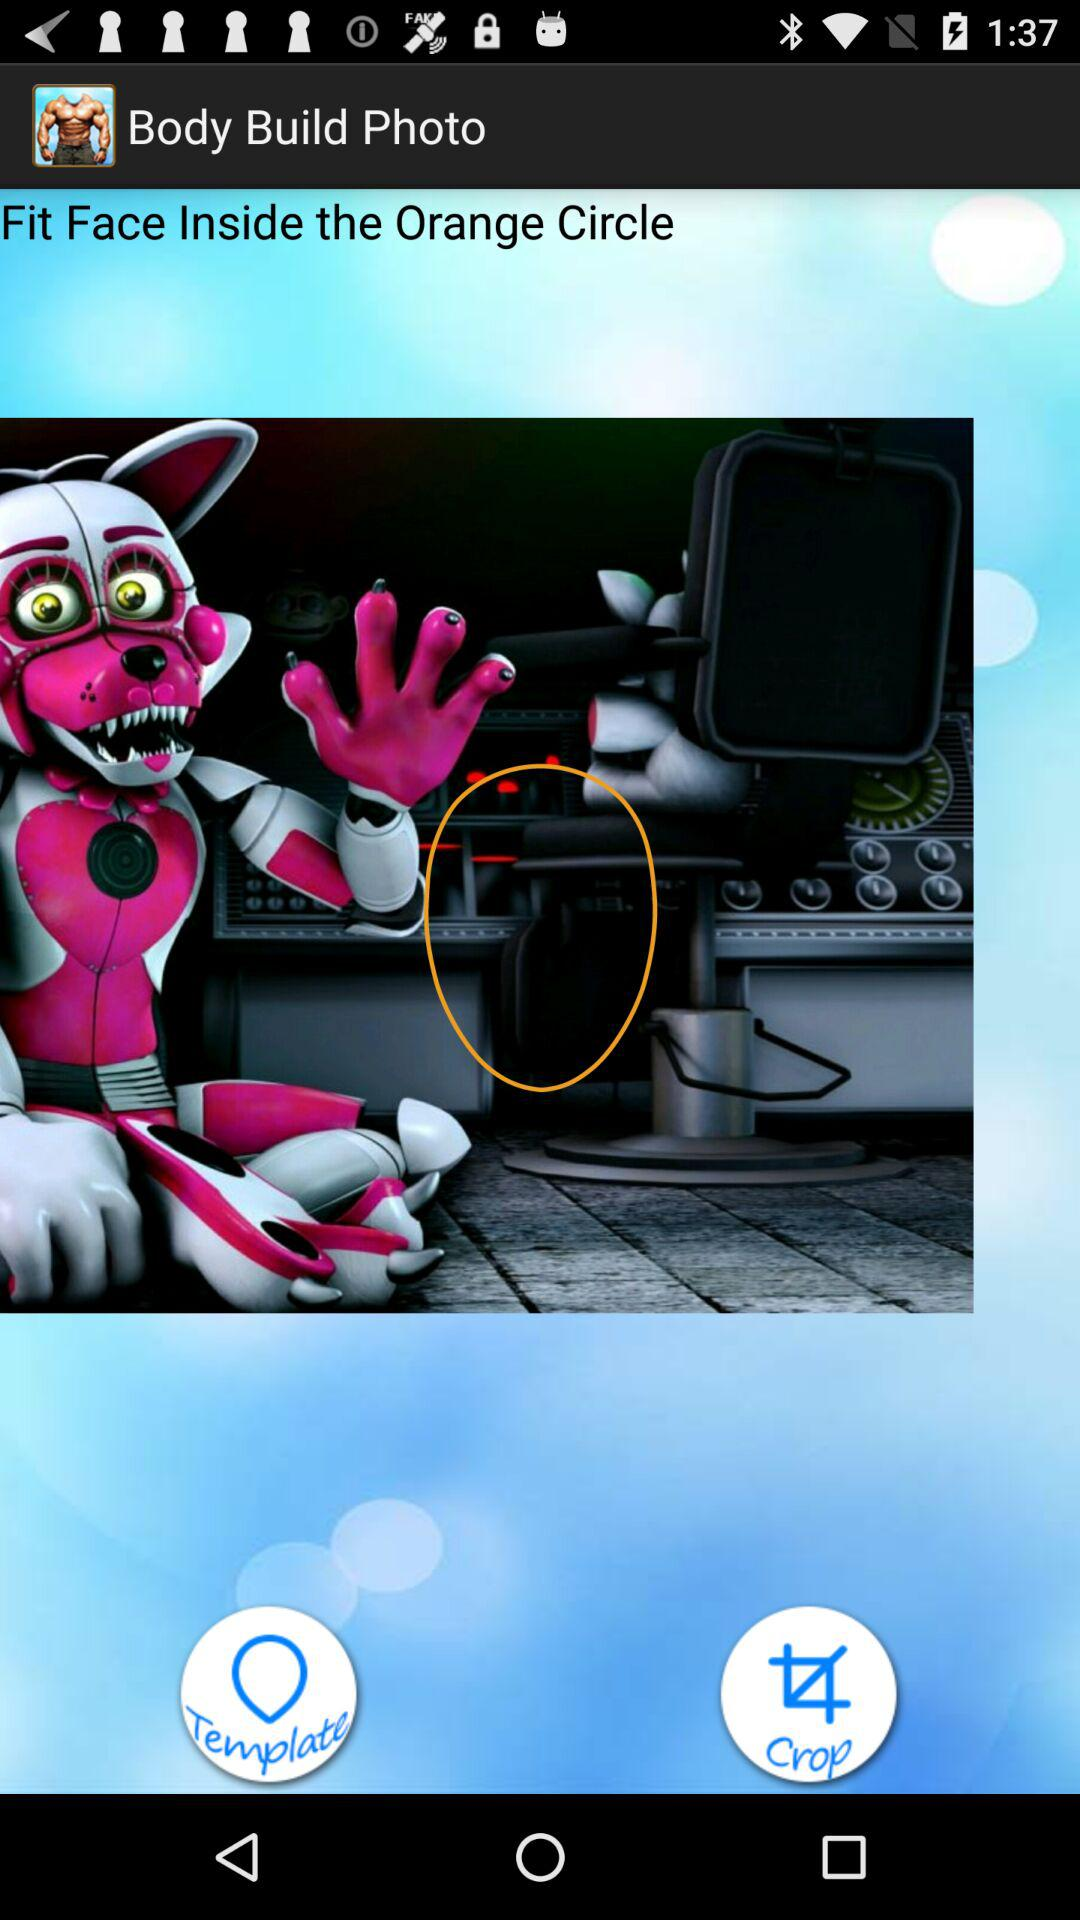What is the application name? The application name is "Body Builder Photo Suit - Home". 